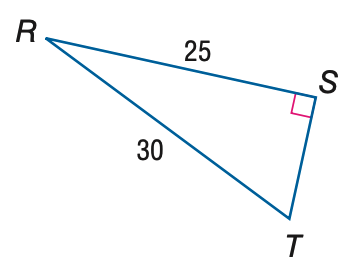Question: Find the measure of \angle T to the nearest tenth.
Choices:
A. 33.6
B. 39.8
C. 50.2
D. 56.4
Answer with the letter. Answer: D 